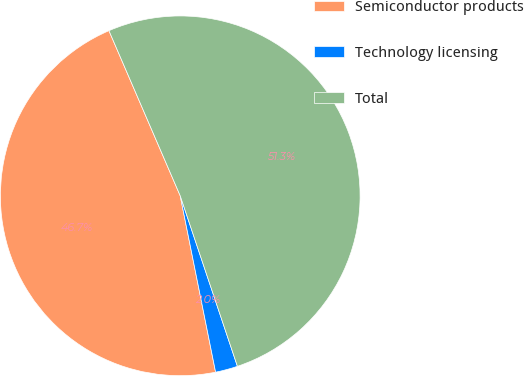<chart> <loc_0><loc_0><loc_500><loc_500><pie_chart><fcel>Semiconductor products<fcel>Technology licensing<fcel>Total<nl><fcel>46.67%<fcel>2.0%<fcel>51.34%<nl></chart> 